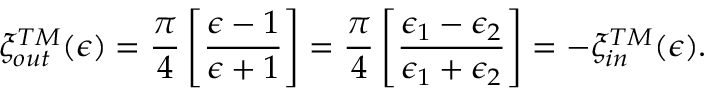Convert formula to latex. <formula><loc_0><loc_0><loc_500><loc_500>\xi _ { o u t } ^ { T M } ( \epsilon ) = { \frac { \pi } { 4 } } \left [ { \frac { \epsilon - 1 } { \epsilon + 1 } } \right ] = { \frac { \pi } { 4 } } \left [ { \frac { \epsilon _ { 1 } - \epsilon _ { 2 } } { \epsilon _ { 1 } + \epsilon _ { 2 } } } \right ] = - \xi _ { i n } ^ { T M } ( \epsilon ) .</formula> 